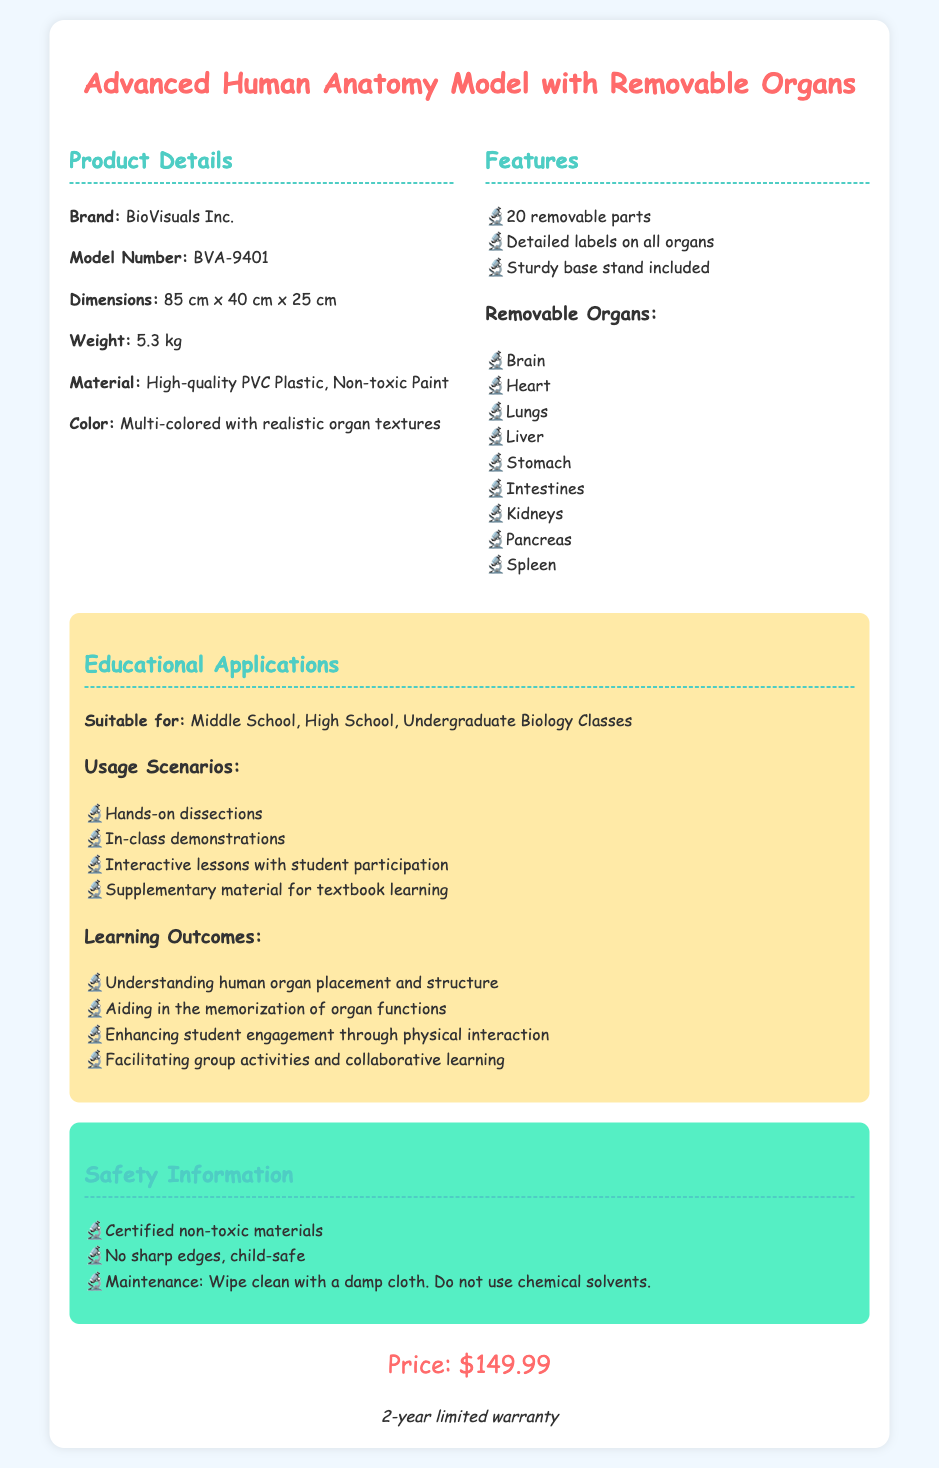What is the brand of the anatomy model? The brand of the anatomy model is specified in the document as BioVisuals Inc.
Answer: BioVisuals Inc How many removable organs does the model have? The model features a total of 20 removable parts as stated in the specifications.
Answer: 20 What are the dimensions of the anatomy model? The dimensions are given in the product details section, measuring 85 cm x 40 cm x 25 cm.
Answer: 85 cm x 40 cm x 25 cm Which safety certification is mentioned for the materials used? The document states that the materials are certified non-toxic, ensuring safety for use.
Answer: Non-toxic What is the main educational application mentioned for this model? The document lists several usage scenarios, and one significant application is for hands-on dissections.
Answer: Hands-on dissections What type of warranty is offered with the model? The warranty information indicates it is a 2-year limited warranty.
Answer: 2-year limited warranty What color is the anatomy model? The color specification states that the model is multi-colored with realistic organ textures.
Answer: Multi-colored Which educational level is the model suitable for? The document mentions that it is suitable for Middle School, High School, and Undergraduate Biology Classes.
Answer: Middle School, High School, Undergraduate Biology Classes What is the price of the anatomy model? The price is clearly stated at the bottom of the document.
Answer: $149.99 